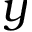<formula> <loc_0><loc_0><loc_500><loc_500>y</formula> 